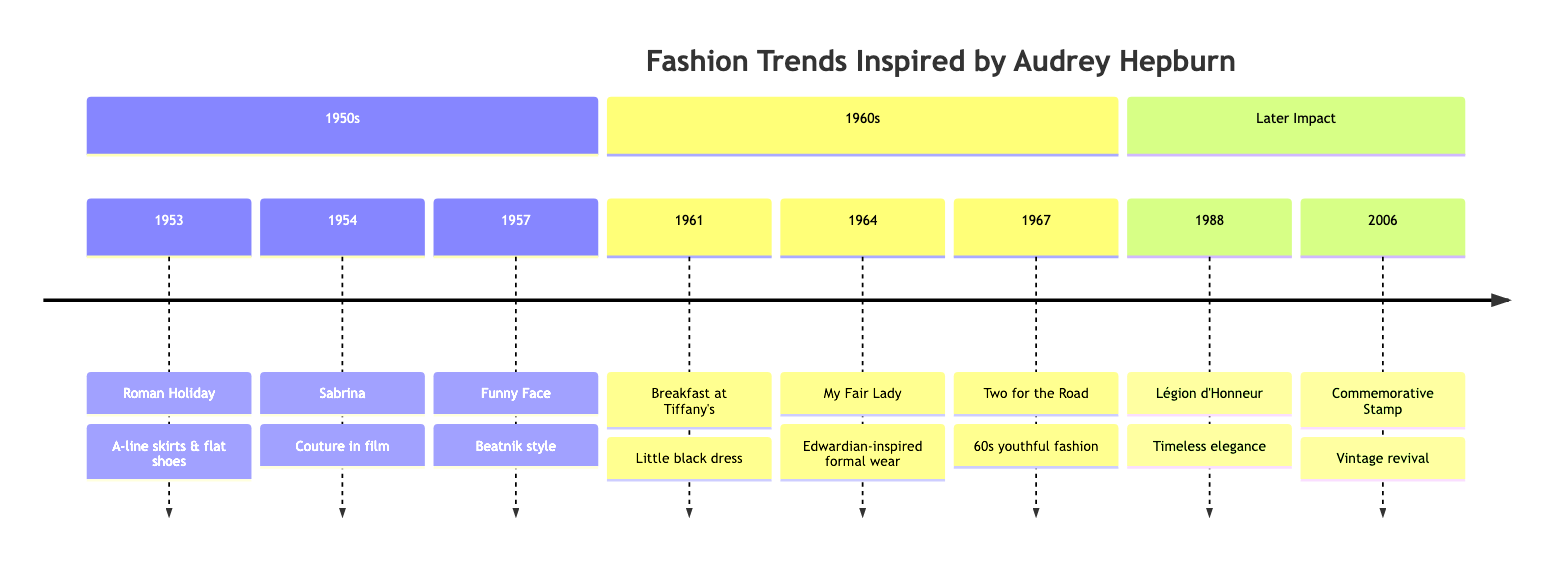What year did Audrey Hepburn star in "Roman Holiday"? The diagram shows that "Roman Holiday" is listed under the year 1953 in the timeline section for the 1950s.
Answer: 1953 What fashion style was popularized by "Funny Face"? The event "Funny Face" is linked with the description that mentions the popularization of beatnik style, which includes elements such as black turtlenecks and skinny pants.
Answer: Beatnik style Which film marked the introduction of the little black dress? The timeline indicates that "Breakfast at Tiffany's" is the film that is associated with the introduction of the little black dress as iconic, worn by Hepburn.
Answer: Breakfast at Tiffany's What did Audrey Hepburn wear in "My Fair Lady"? The entry for "My Fair Lady" indicates that Hepburn wears extravagant costumes and Edwardian style, with elements such as off-the-shoulder gowns and gloves.
Answer: Extravagant costumes In what decade did Audrey Hepburn influence the trend toward youthful fashion? The timeline shows that "Two for the Road," which features youthful outfits and bold patterns, is listed in the 1960s section of the timeline.
Answer: 1960s How many films are listed under the 1960s section? The 1960s section contains three specific events highlighted by their titles: "Breakfast at Tiffany's," "My Fair Lady," and "Two for the Road."
Answer: 3 What was the impact of the 2006 commemorative stamp? The 2006 entry specifies that the stamp reignited interest in Hepburn's fashion legacy, influencing modern collections towards vintage and retro trends.
Answer: Vintage revival Which event comes after "Sabrina" in the timeline? By looking at the timeline order, the event listed after "Sabrina" (1954) is "Funny Face" (1957).
Answer: Funny Face Which fashion designer collaborated with Hepburn for "Sabrina"? The description associated with the event "Sabrina" indicates that Hubert de Givenchy collaborated with Hepburn for her iconic looks in the film.
Answer: Hubert de Givenchy 